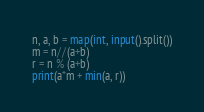<code> <loc_0><loc_0><loc_500><loc_500><_Python_>n, a, b = map(int, input().split())
m = n//(a+b)
r = n % (a+b)
print(a*m + min(a, r))</code> 